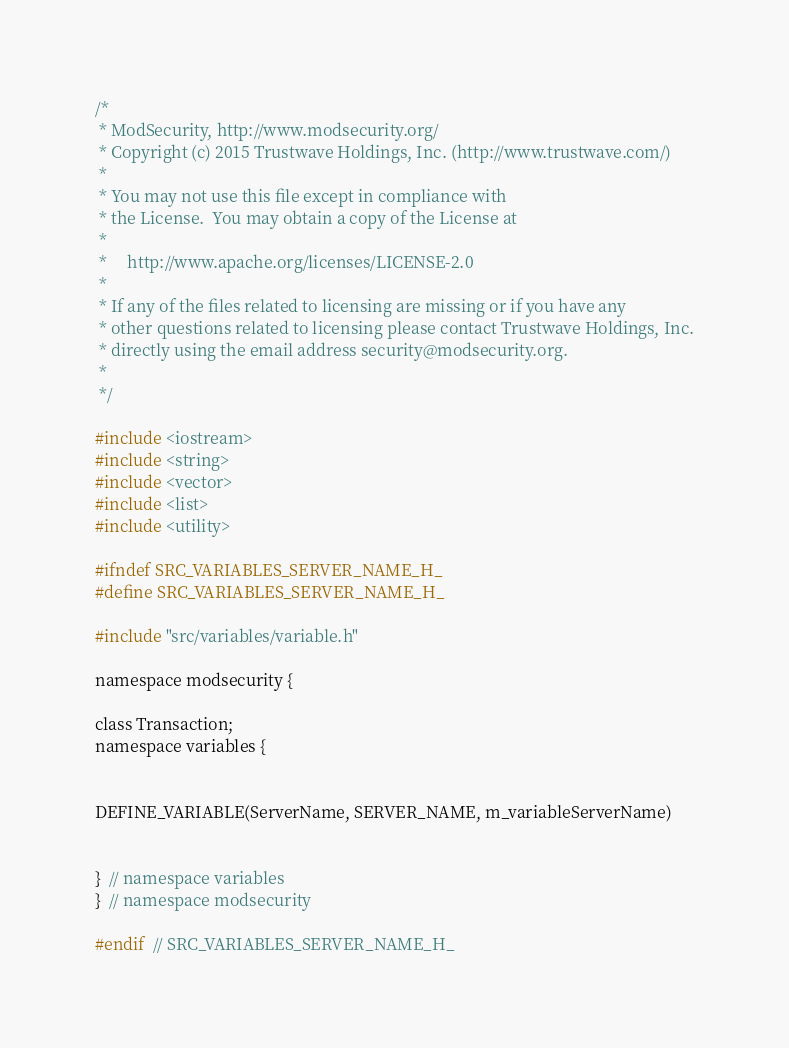<code> <loc_0><loc_0><loc_500><loc_500><_C_>/*
 * ModSecurity, http://www.modsecurity.org/
 * Copyright (c) 2015 Trustwave Holdings, Inc. (http://www.trustwave.com/)
 *
 * You may not use this file except in compliance with
 * the License.  You may obtain a copy of the License at
 *
 *     http://www.apache.org/licenses/LICENSE-2.0
 *
 * If any of the files related to licensing are missing or if you have any
 * other questions related to licensing please contact Trustwave Holdings, Inc.
 * directly using the email address security@modsecurity.org.
 *
 */

#include <iostream>
#include <string>
#include <vector>
#include <list>
#include <utility>

#ifndef SRC_VARIABLES_SERVER_NAME_H_
#define SRC_VARIABLES_SERVER_NAME_H_

#include "src/variables/variable.h"

namespace modsecurity {

class Transaction;
namespace variables {


DEFINE_VARIABLE(ServerName, SERVER_NAME, m_variableServerName)


}  // namespace variables
}  // namespace modsecurity

#endif  // SRC_VARIABLES_SERVER_NAME_H_
</code> 